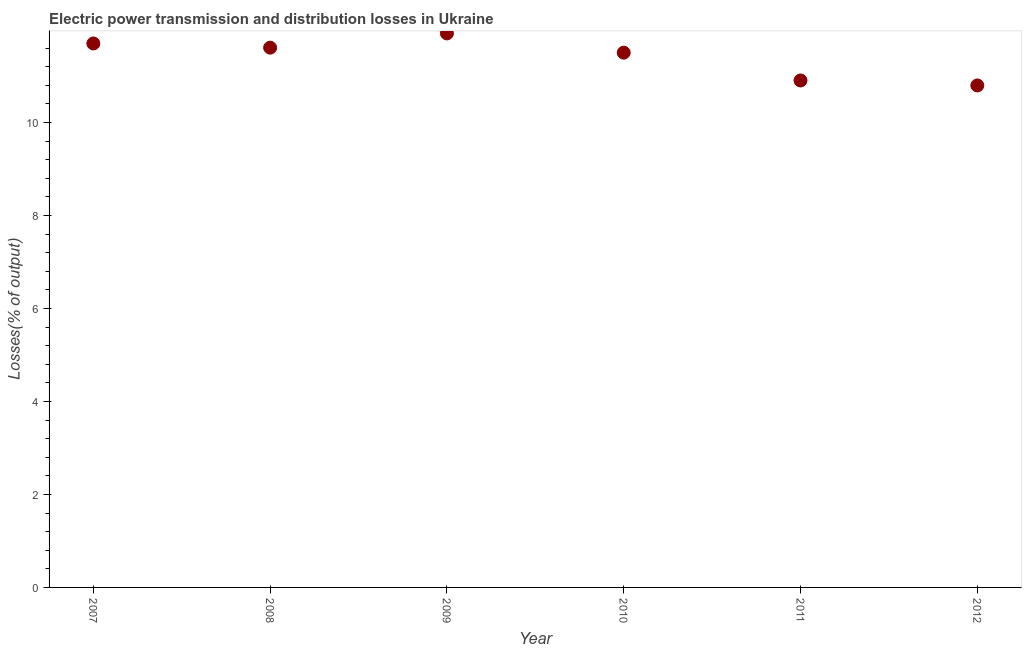What is the electric power transmission and distribution losses in 2011?
Give a very brief answer. 10.91. Across all years, what is the maximum electric power transmission and distribution losses?
Give a very brief answer. 11.92. Across all years, what is the minimum electric power transmission and distribution losses?
Make the answer very short. 10.8. In which year was the electric power transmission and distribution losses maximum?
Provide a succinct answer. 2009. What is the sum of the electric power transmission and distribution losses?
Your response must be concise. 68.44. What is the difference between the electric power transmission and distribution losses in 2010 and 2011?
Offer a very short reply. 0.6. What is the average electric power transmission and distribution losses per year?
Make the answer very short. 11.41. What is the median electric power transmission and distribution losses?
Your answer should be very brief. 11.56. In how many years, is the electric power transmission and distribution losses greater than 11.2 %?
Your answer should be very brief. 4. Do a majority of the years between 2009 and 2011 (inclusive) have electric power transmission and distribution losses greater than 3.2 %?
Ensure brevity in your answer.  Yes. What is the ratio of the electric power transmission and distribution losses in 2007 to that in 2009?
Keep it short and to the point. 0.98. Is the electric power transmission and distribution losses in 2007 less than that in 2010?
Offer a very short reply. No. What is the difference between the highest and the second highest electric power transmission and distribution losses?
Provide a short and direct response. 0.22. Is the sum of the electric power transmission and distribution losses in 2008 and 2009 greater than the maximum electric power transmission and distribution losses across all years?
Provide a short and direct response. Yes. What is the difference between the highest and the lowest electric power transmission and distribution losses?
Offer a terse response. 1.12. In how many years, is the electric power transmission and distribution losses greater than the average electric power transmission and distribution losses taken over all years?
Offer a terse response. 4. Does the electric power transmission and distribution losses monotonically increase over the years?
Your response must be concise. No. What is the difference between two consecutive major ticks on the Y-axis?
Provide a succinct answer. 2. What is the title of the graph?
Offer a very short reply. Electric power transmission and distribution losses in Ukraine. What is the label or title of the X-axis?
Provide a succinct answer. Year. What is the label or title of the Y-axis?
Give a very brief answer. Losses(% of output). What is the Losses(% of output) in 2007?
Offer a terse response. 11.7. What is the Losses(% of output) in 2008?
Offer a very short reply. 11.61. What is the Losses(% of output) in 2009?
Your response must be concise. 11.92. What is the Losses(% of output) in 2010?
Give a very brief answer. 11.5. What is the Losses(% of output) in 2011?
Offer a very short reply. 10.91. What is the Losses(% of output) in 2012?
Provide a succinct answer. 10.8. What is the difference between the Losses(% of output) in 2007 and 2008?
Provide a short and direct response. 0.09. What is the difference between the Losses(% of output) in 2007 and 2009?
Your answer should be compact. -0.22. What is the difference between the Losses(% of output) in 2007 and 2010?
Offer a very short reply. 0.2. What is the difference between the Losses(% of output) in 2007 and 2011?
Your response must be concise. 0.8. What is the difference between the Losses(% of output) in 2007 and 2012?
Your answer should be very brief. 0.9. What is the difference between the Losses(% of output) in 2008 and 2009?
Ensure brevity in your answer.  -0.31. What is the difference between the Losses(% of output) in 2008 and 2010?
Provide a short and direct response. 0.11. What is the difference between the Losses(% of output) in 2008 and 2011?
Your response must be concise. 0.71. What is the difference between the Losses(% of output) in 2008 and 2012?
Offer a very short reply. 0.81. What is the difference between the Losses(% of output) in 2009 and 2010?
Give a very brief answer. 0.41. What is the difference between the Losses(% of output) in 2009 and 2011?
Offer a terse response. 1.01. What is the difference between the Losses(% of output) in 2009 and 2012?
Your response must be concise. 1.12. What is the difference between the Losses(% of output) in 2010 and 2011?
Offer a very short reply. 0.6. What is the difference between the Losses(% of output) in 2010 and 2012?
Keep it short and to the point. 0.71. What is the difference between the Losses(% of output) in 2011 and 2012?
Your answer should be very brief. 0.11. What is the ratio of the Losses(% of output) in 2007 to that in 2011?
Your answer should be compact. 1.07. What is the ratio of the Losses(% of output) in 2007 to that in 2012?
Ensure brevity in your answer.  1.08. What is the ratio of the Losses(% of output) in 2008 to that in 2009?
Make the answer very short. 0.97. What is the ratio of the Losses(% of output) in 2008 to that in 2011?
Ensure brevity in your answer.  1.06. What is the ratio of the Losses(% of output) in 2008 to that in 2012?
Make the answer very short. 1.07. What is the ratio of the Losses(% of output) in 2009 to that in 2010?
Your answer should be compact. 1.04. What is the ratio of the Losses(% of output) in 2009 to that in 2011?
Offer a terse response. 1.09. What is the ratio of the Losses(% of output) in 2009 to that in 2012?
Ensure brevity in your answer.  1.1. What is the ratio of the Losses(% of output) in 2010 to that in 2011?
Provide a short and direct response. 1.05. What is the ratio of the Losses(% of output) in 2010 to that in 2012?
Provide a short and direct response. 1.06. 